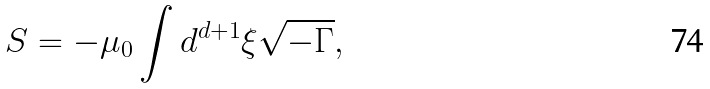<formula> <loc_0><loc_0><loc_500><loc_500>S = - \mu _ { 0 } \int d ^ { d + 1 } \xi \sqrt { - \Gamma } ,</formula> 